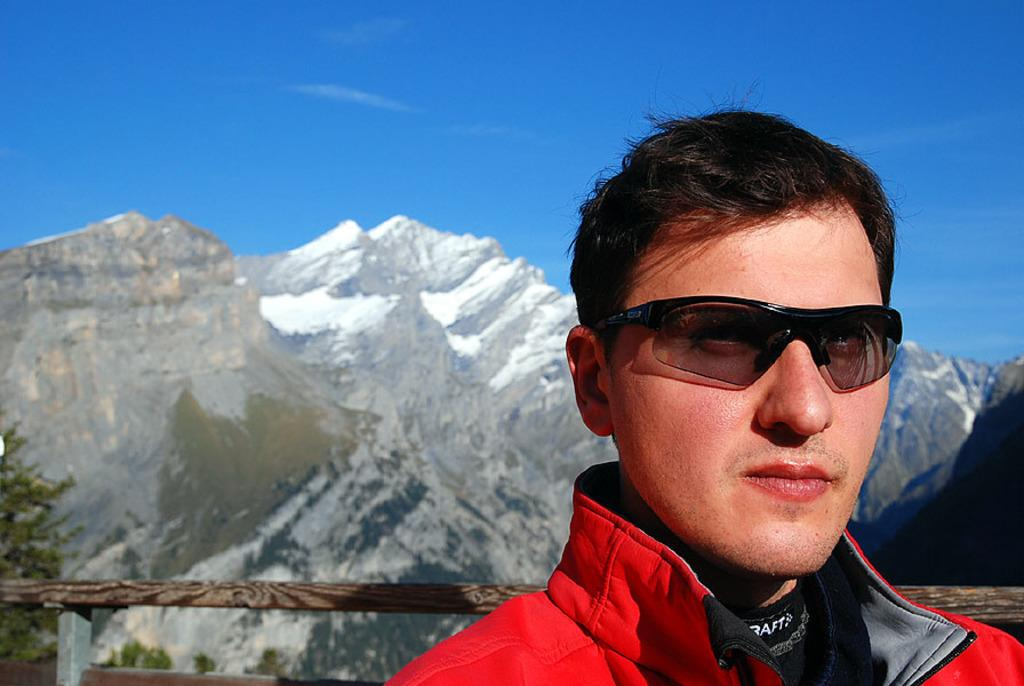Who is present in the image? There is a man in the image. What is the man wearing on his face? The man is wearing goggles. What type of barrier can be seen in the image? There is a wooden fence in the image. What can be seen in the distance in the image? There are trees and a mountain in the background of the image. What is the color of the sky in the image? The sky is blue in the image. What type of badge is the man wearing on his shirt in the image? There is no badge visible on the man's shirt in the image. Can you tell me how many icicles are hanging from the trees in the image? There are no icicles present in the image, as it is set in a blue-sky environment with trees and a mountain in the background. 